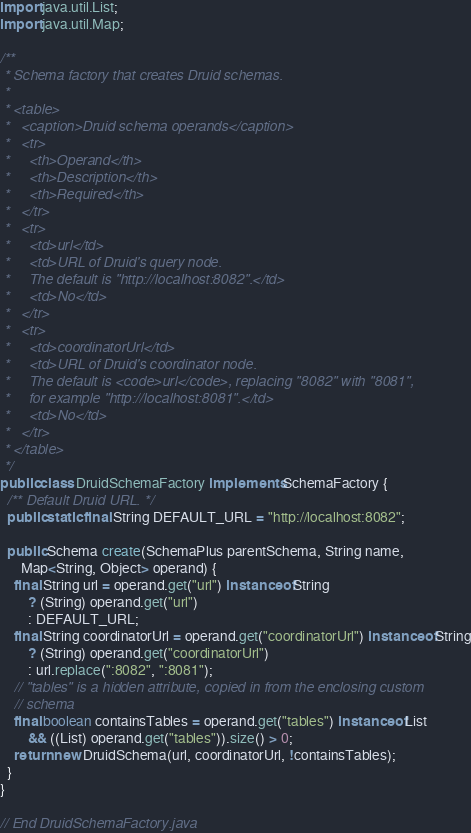<code> <loc_0><loc_0><loc_500><loc_500><_Java_>
import java.util.List;
import java.util.Map;

/**
 * Schema factory that creates Druid schemas.
 *
 * <table>
 *   <caption>Druid schema operands</caption>
 *   <tr>
 *     <th>Operand</th>
 *     <th>Description</th>
 *     <th>Required</th>
 *   </tr>
 *   <tr>
 *     <td>url</td>
 *     <td>URL of Druid's query node.
 *     The default is "http://localhost:8082".</td>
 *     <td>No</td>
 *   </tr>
 *   <tr>
 *     <td>coordinatorUrl</td>
 *     <td>URL of Druid's coordinator node.
 *     The default is <code>url</code>, replacing "8082" with "8081",
 *     for example "http://localhost:8081".</td>
 *     <td>No</td>
 *   </tr>
 * </table>
 */
public class DruidSchemaFactory implements SchemaFactory {
  /** Default Druid URL. */
  public static final String DEFAULT_URL = "http://localhost:8082";

  public Schema create(SchemaPlus parentSchema, String name,
      Map<String, Object> operand) {
    final String url = operand.get("url") instanceof String
        ? (String) operand.get("url")
        : DEFAULT_URL;
    final String coordinatorUrl = operand.get("coordinatorUrl") instanceof String
        ? (String) operand.get("coordinatorUrl")
        : url.replace(":8082", ":8081");
    // "tables" is a hidden attribute, copied in from the enclosing custom
    // schema
    final boolean containsTables = operand.get("tables") instanceof List
        && ((List) operand.get("tables")).size() > 0;
    return new DruidSchema(url, coordinatorUrl, !containsTables);
  }
}

// End DruidSchemaFactory.java
</code> 